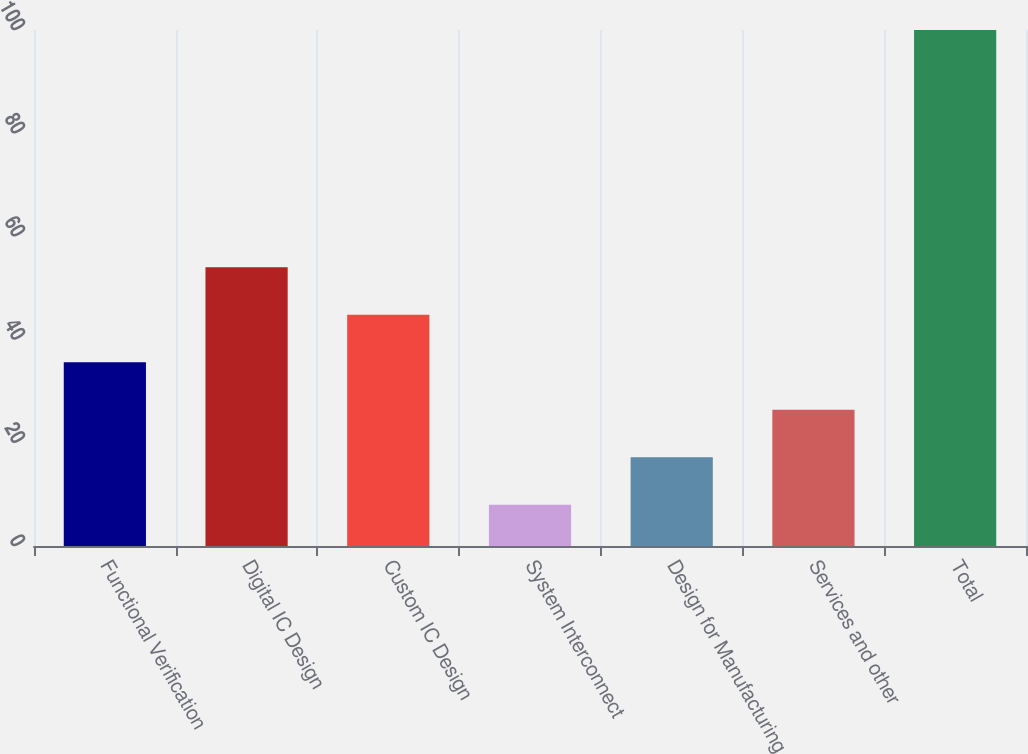Convert chart. <chart><loc_0><loc_0><loc_500><loc_500><bar_chart><fcel>Functional Verification<fcel>Digital IC Design<fcel>Custom IC Design<fcel>System Interconnect<fcel>Design for Manufacturing<fcel>Services and other<fcel>Total<nl><fcel>35.6<fcel>54<fcel>44.8<fcel>8<fcel>17.2<fcel>26.4<fcel>100<nl></chart> 